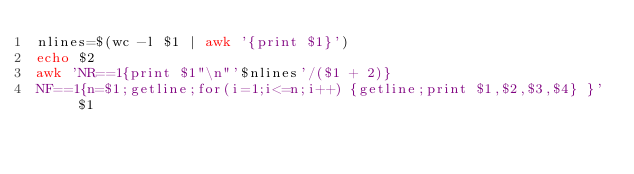<code> <loc_0><loc_0><loc_500><loc_500><_Bash_>nlines=$(wc -l $1 | awk '{print $1}')
echo $2
awk 'NR==1{print $1"\n"'$nlines'/($1 + 2)}
NF==1{n=$1;getline;for(i=1;i<=n;i++) {getline;print $1,$2,$3,$4} }' $1 
</code> 